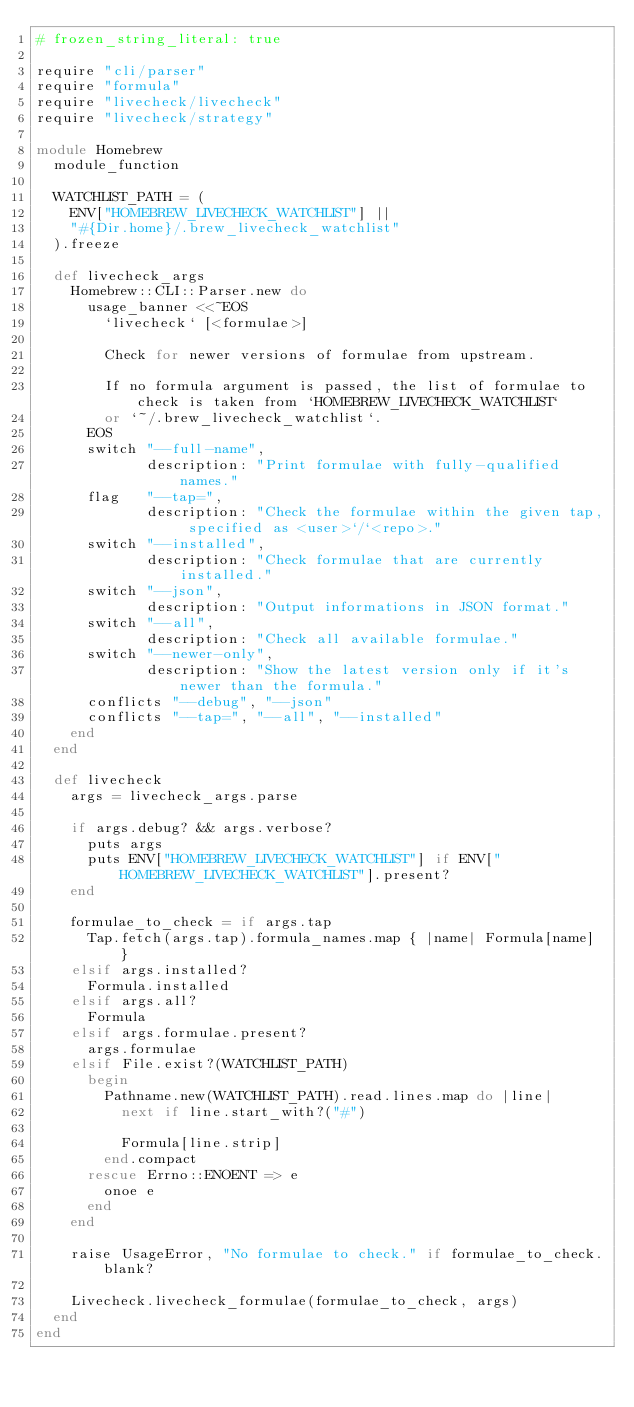Convert code to text. <code><loc_0><loc_0><loc_500><loc_500><_Ruby_># frozen_string_literal: true

require "cli/parser"
require "formula"
require "livecheck/livecheck"
require "livecheck/strategy"

module Homebrew
  module_function

  WATCHLIST_PATH = (
    ENV["HOMEBREW_LIVECHECK_WATCHLIST"] ||
    "#{Dir.home}/.brew_livecheck_watchlist"
  ).freeze

  def livecheck_args
    Homebrew::CLI::Parser.new do
      usage_banner <<~EOS
        `livecheck` [<formulae>]

        Check for newer versions of formulae from upstream.

        If no formula argument is passed, the list of formulae to check is taken from `HOMEBREW_LIVECHECK_WATCHLIST`
        or `~/.brew_livecheck_watchlist`.
      EOS
      switch "--full-name",
             description: "Print formulae with fully-qualified names."
      flag   "--tap=",
             description: "Check the formulae within the given tap, specified as <user>`/`<repo>."
      switch "--installed",
             description: "Check formulae that are currently installed."
      switch "--json",
             description: "Output informations in JSON format."
      switch "--all",
             description: "Check all available formulae."
      switch "--newer-only",
             description: "Show the latest version only if it's newer than the formula."
      conflicts "--debug", "--json"
      conflicts "--tap=", "--all", "--installed"
    end
  end

  def livecheck
    args = livecheck_args.parse

    if args.debug? && args.verbose?
      puts args
      puts ENV["HOMEBREW_LIVECHECK_WATCHLIST"] if ENV["HOMEBREW_LIVECHECK_WATCHLIST"].present?
    end

    formulae_to_check = if args.tap
      Tap.fetch(args.tap).formula_names.map { |name| Formula[name] }
    elsif args.installed?
      Formula.installed
    elsif args.all?
      Formula
    elsif args.formulae.present?
      args.formulae
    elsif File.exist?(WATCHLIST_PATH)
      begin
        Pathname.new(WATCHLIST_PATH).read.lines.map do |line|
          next if line.start_with?("#")

          Formula[line.strip]
        end.compact
      rescue Errno::ENOENT => e
        onoe e
      end
    end

    raise UsageError, "No formulae to check." if formulae_to_check.blank?

    Livecheck.livecheck_formulae(formulae_to_check, args)
  end
end
</code> 